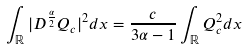Convert formula to latex. <formula><loc_0><loc_0><loc_500><loc_500>\int _ { \mathbb { R } } | D ^ { \frac { \alpha } 2 } Q _ { c } | ^ { 2 } d x = \frac { c } { 3 \alpha - 1 } \int _ { \mathbb { R } } Q _ { c } ^ { 2 } d x</formula> 